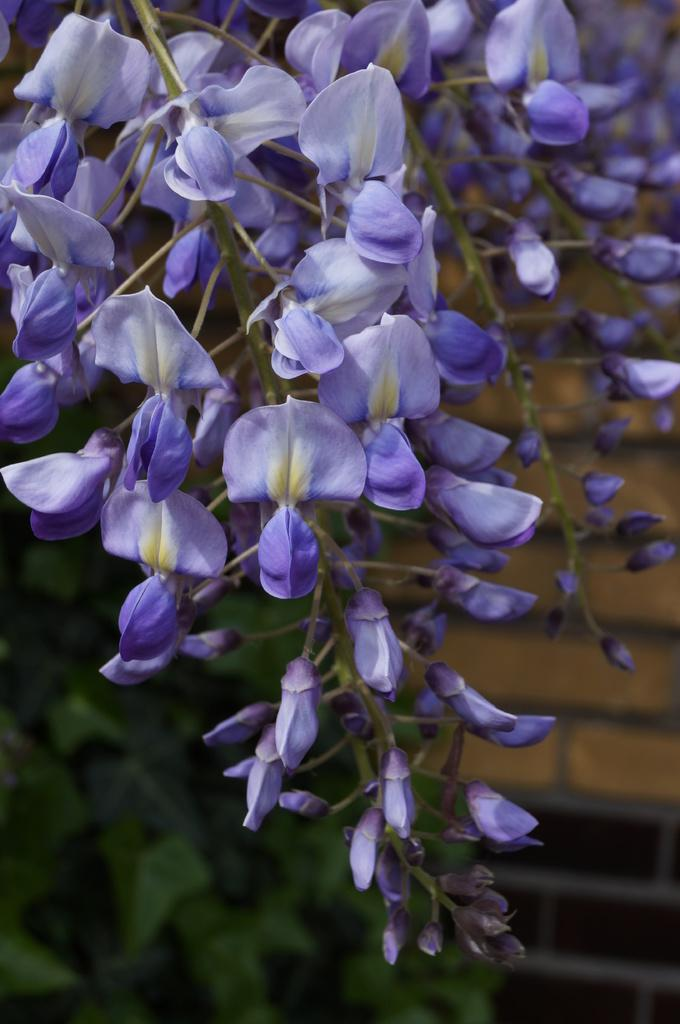What type of plants can be seen in the image? There are flowers in the image. What can be seen in the background of the image? There are leaves and a wall. What type of cave can be seen in the image? There is no cave present in the image. What type of trousers are the flowers wearing in the image? Flowers do not wear trousers, as they are plants and not human beings. 